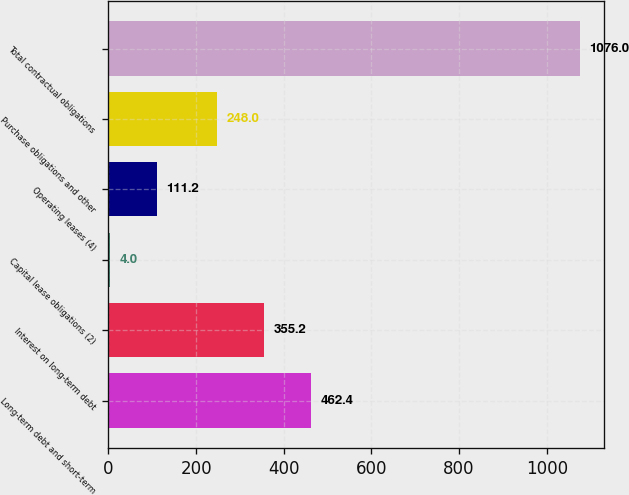Convert chart to OTSL. <chart><loc_0><loc_0><loc_500><loc_500><bar_chart><fcel>Long-term debt and short-term<fcel>Interest on long-term debt<fcel>Capital lease obligations (2)<fcel>Operating leases (4)<fcel>Purchase obligations and other<fcel>Total contractual obligations<nl><fcel>462.4<fcel>355.2<fcel>4<fcel>111.2<fcel>248<fcel>1076<nl></chart> 